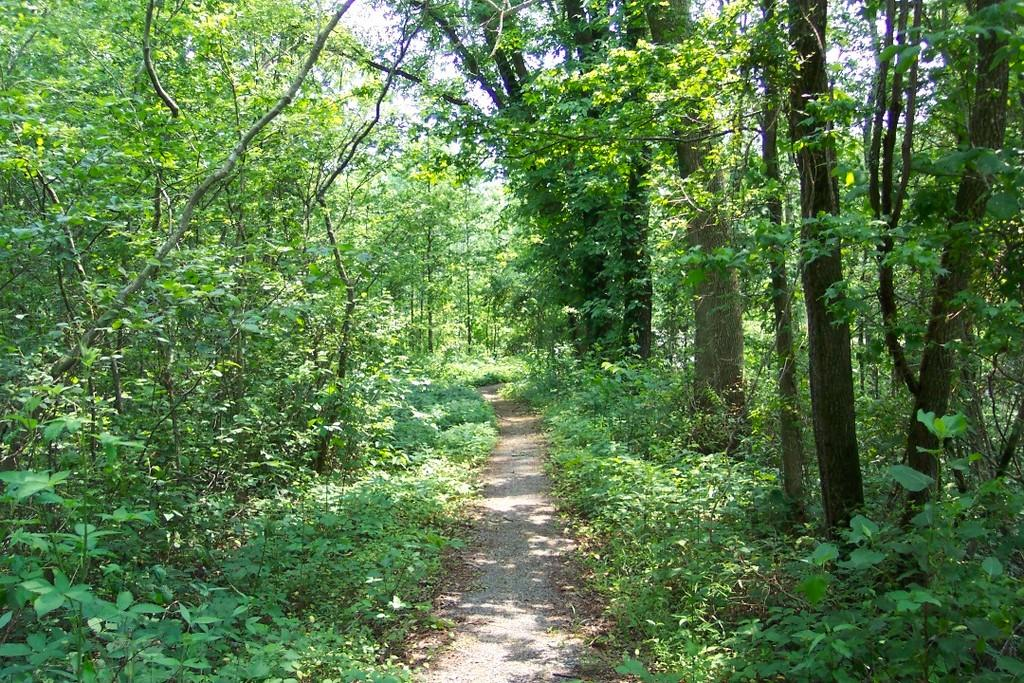What type of path is visible in the image? There is a walkway in the image. What can be seen on the left side of the image? There are trees on the left side of the image. What can be seen on the right side of the image? There are trees on the right side of the image. What is visible at the top of the image? The sky is clear and visible at the top of the image. What type of committee is meeting under the trees in the image? There is no committee meeting in the image; it only shows a walkway with trees on both sides and a clear sky above. 